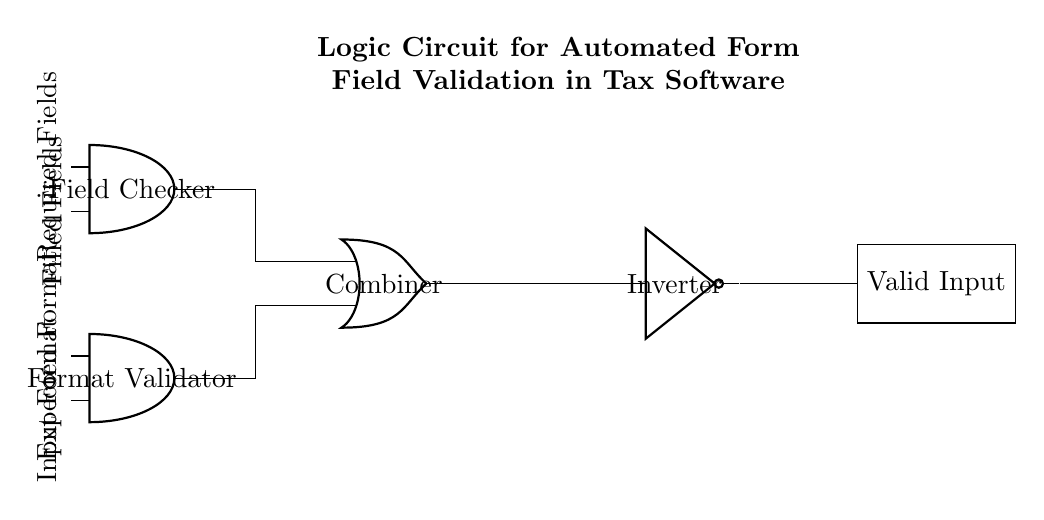What are the types of gates in the circuit? The circuit includes AND, OR, and NOT gates. The AND gates check conditions, the OR gate combines outputs, and the NOT gate inverts the output.
Answer: AND, OR, NOT What is the purpose of the AND gate named "Field Checker"? The "Field Checker" AND gate validates that both required fields are filled out, ensuring that necessary input is provided for processing.
Answer: Validate input How many inputs does the "Combiner" OR gate receive? The OR gate receives inputs from two AND gates, which results in a total of two inputs into the "Combiner".
Answer: Two What is the function of the NOT gate in this circuit? The NOT gate inverts the output from the OR gate, which means if the OR gate outputs a valid signal, the NOT gate will change it to an invalid signal, alerting that the input is not correct.
Answer: Invert output What are the signal sources feeding into the AND gates? The AND gates receive signals from filled fields and required fields (for the "Field Checker") and from expected format and input format (for the "Format Validator").
Answer: Filled fields, required fields, expected format, input format What does the output labeled "Valid Input" indicate? The "Valid Input" output indicates whether the combined logic from the AND and OR gates confirms that the input fields have been correctly filled according to the expected criteria.
Answer: Valid input confirmation 